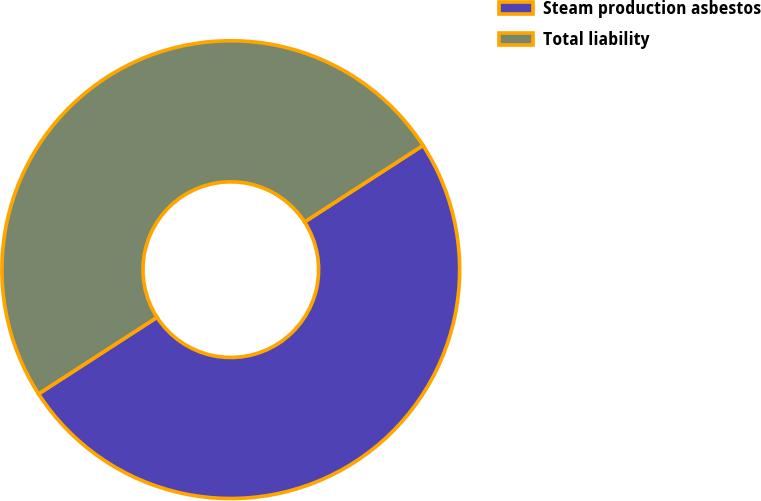Convert chart to OTSL. <chart><loc_0><loc_0><loc_500><loc_500><pie_chart><fcel>Steam production asbestos<fcel>Total liability<nl><fcel>50.0%<fcel>50.0%<nl></chart> 